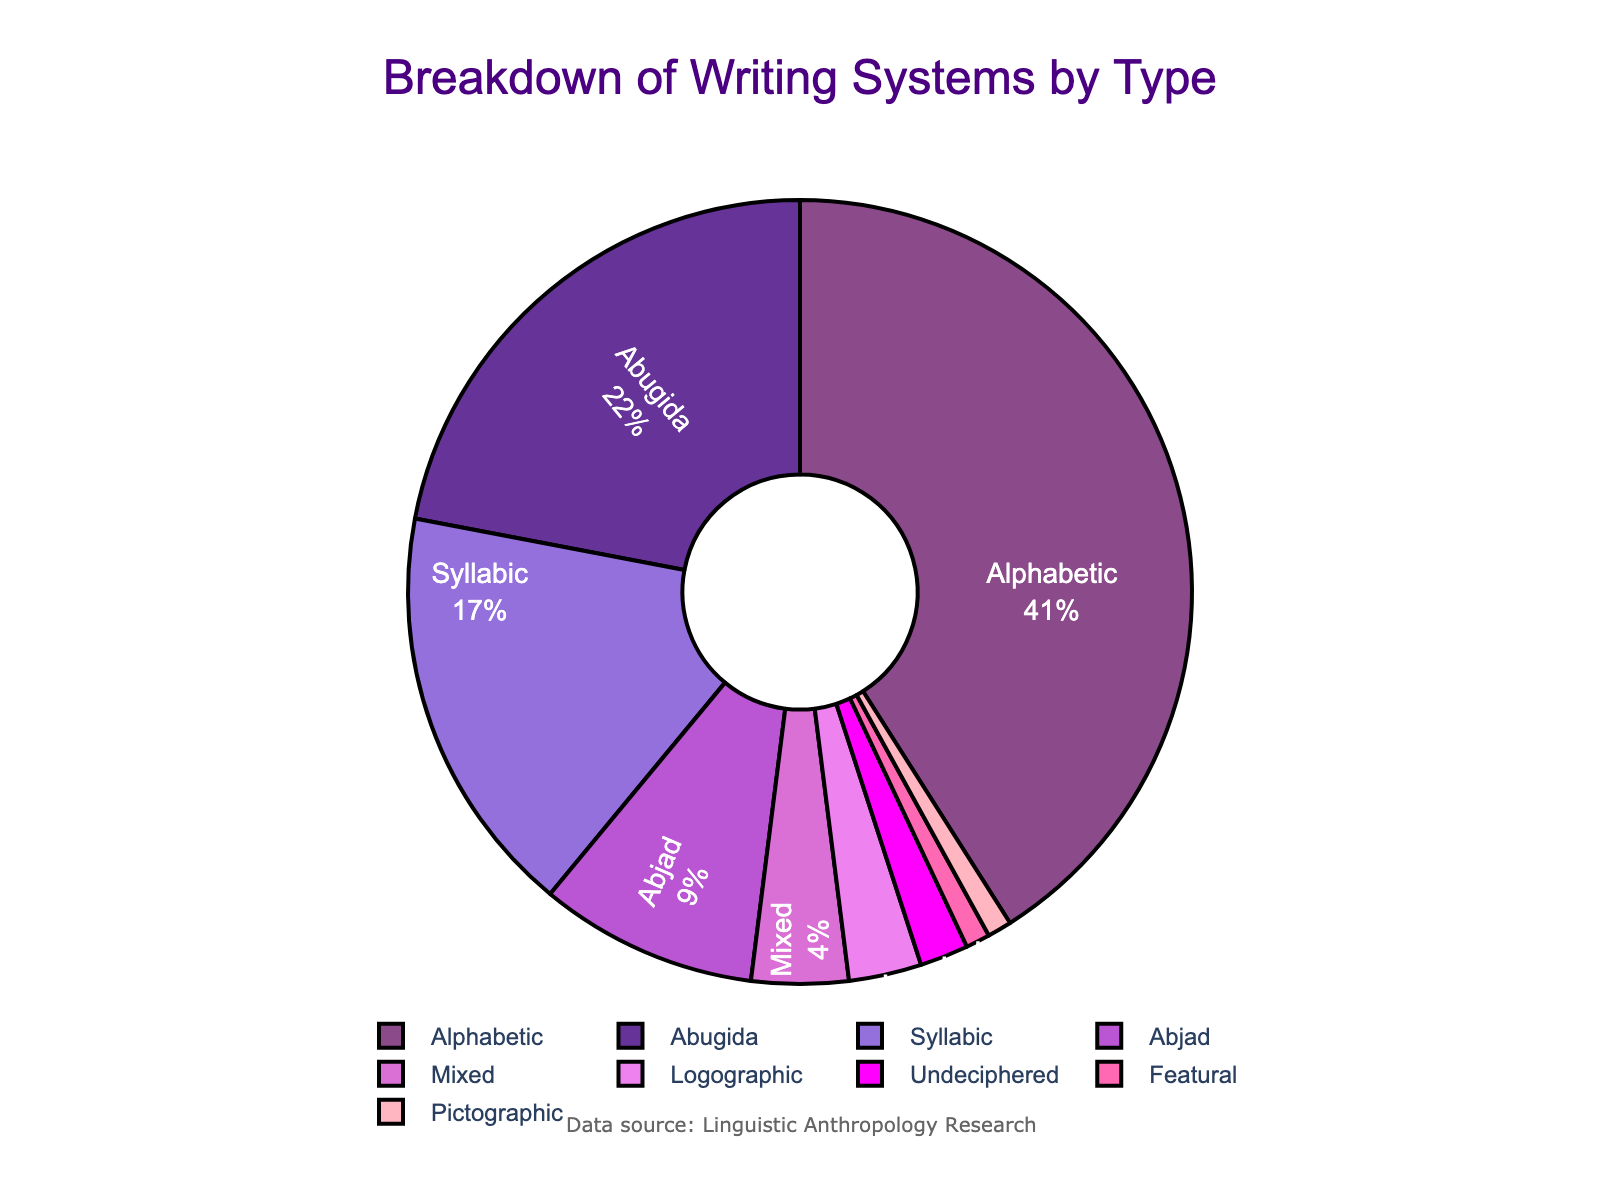What's the largest section in the pie chart? The largest section in the pie chart represents the writing system type with the highest percentage. By looking at the chart, it is clear that the "Alphabetic" section is the largest.
Answer: Alphabetic Which writing systems together make up less than 5% of the total? To find the writing systems that make up less than 5%, identify the sections with percentages below 5%. The sections labeled "Logographic" (3%), "Featural" (1%), "Undeciphered" (2%), and "Pictographic" (1%) all fit this criterion.
Answer: Logographic, Featural, Undeciphered, Pictographic What is the combined percentage of Alphabetic and Abugida writing systems? Add the percentages of the "Alphabetic" (41%) and "Abugida" (22%) writing systems. 41 + 22 = 63%.
Answer: 63% Is the percentage of Syllabic writing systems greater than that of Abjad writing systems? Compare the percentages for "Syllabic" (17%) and "Abjad" (9%). Since 17 is greater than 9, the percentage of Syllabic writing systems is indeed greater.
Answer: Yes Which color represents the Syllabic writing systems? Identify the color associated with the "Syllabic" label in the pie chart. The "Syllabic" section is shown in the second color, which is a shade of purple.
Answer: Purple How many writing systems types constitute more than 20% each? Determine which sections have percentages greater than 20%. "Alphabetic" (41%) and "Abugida" (22%) fit this criteria. These are 2 writing system types.
Answer: 2 What is the smallest section in the pie chart? To determine the smallest section, look for the section with the lowest percentage. The "Featural" and "Pictographic" sections both have the smallest value at 1%.
Answer: Featural, Pictographic Which occupies a greater percentage: Mixed or Undeciphered systems? Compare the percentages of "Mixed" (4%) and "Undeciphered" (2%). Since 4 is greater than 2, "Mixed" writing systems occupy a greater percentage.
Answer: Mixed If the Logographic percentage doubled, would it surpass the Abjad percentage? Double the Logographic percentage (3%): 2 * 3% = 6%. Compare this to the Abjad percentage (9%). Since 6% is less than 9%, even if doubled, the Logographic would not surpass Abjad.
Answer: No 